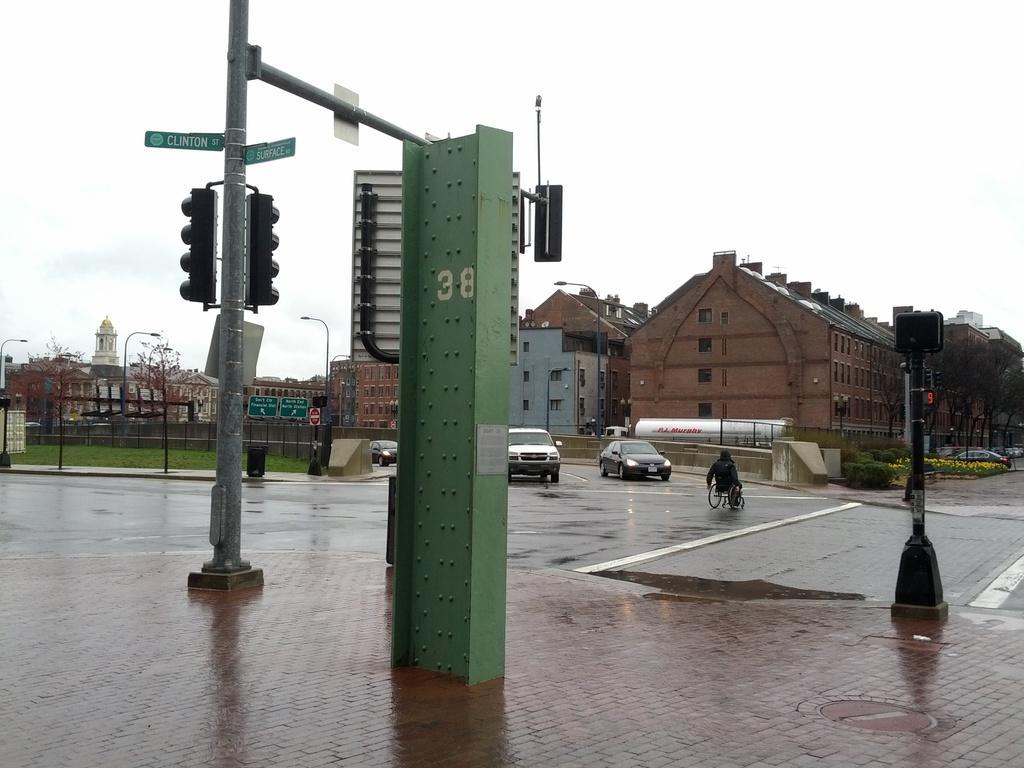Please provide a concise description of this image. In this picture I can see the vehicles on the road. I can see the traffic light poles. I can see a person in the wheelchair. I can see the buildings in the background. I can see green grass. I can see clouds in the sky. I can see trees on the right side. 